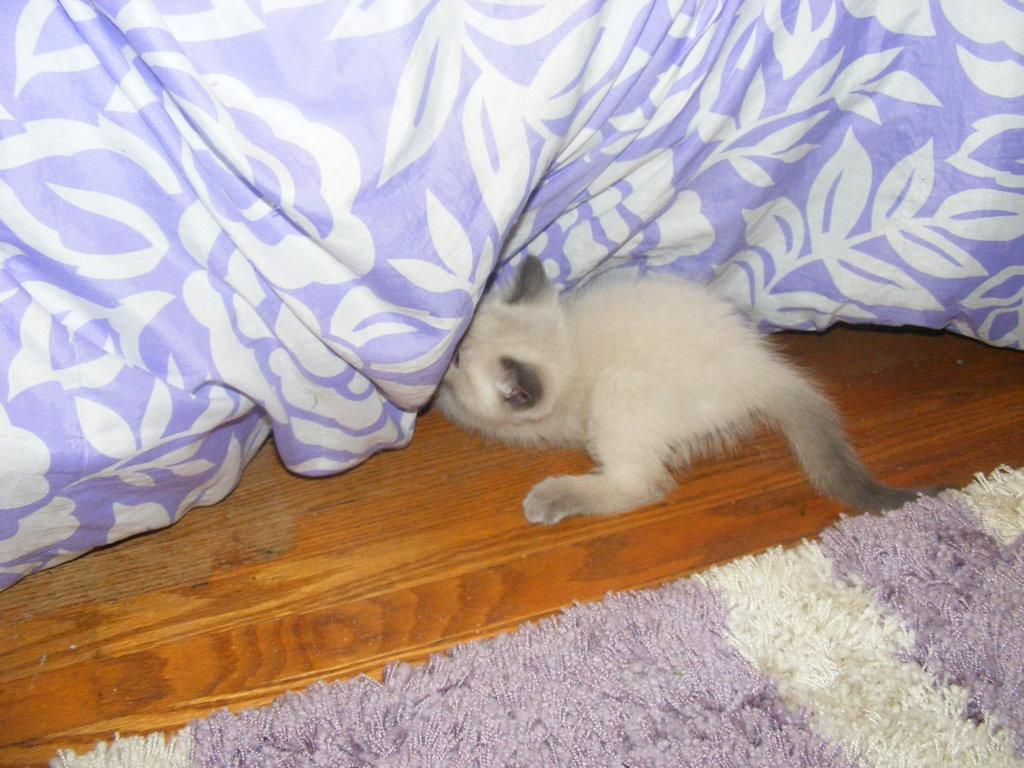What type of animal is present in the image? There is an animal in the image, but its specific type cannot be determined from the provided facts. What is the bed sheet used for in the image? The bed sheet is present in the image, but its purpose or use cannot be determined from the provided facts. What is the mat used for in the image? The mat is present in the image, but its purpose or use cannot be determined from the provided facts. Where are all of these objects located in the image? All of these objects, including the animal, bed sheet, and mat, are located on a platform in the image. How does the hen interact with the copy machine in the image? There is no hen or copy machine present in the image. What type of mouth does the animal have in the image? The specific type of mouth the animal has cannot be determined from the provided facts. 